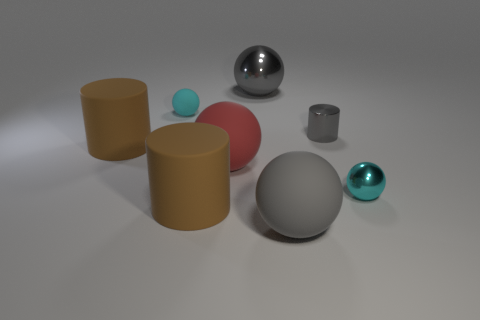There is a rubber thing that is the same color as the big metal thing; what size is it?
Keep it short and to the point. Large. What shape is the other metallic thing that is the same color as the big shiny thing?
Give a very brief answer. Cylinder. How many things are small gray shiny objects or tiny cyan things on the left side of the small shiny cylinder?
Give a very brief answer. 2. Is the size of the gray sphere in front of the red matte thing the same as the large red matte sphere?
Keep it short and to the point. Yes. What material is the small cyan sphere that is to the right of the small cyan rubber object?
Provide a succinct answer. Metal. Are there the same number of large gray rubber objects on the right side of the big red rubber thing and large brown matte objects to the right of the gray rubber object?
Keep it short and to the point. No. The other tiny shiny object that is the same shape as the red thing is what color?
Your answer should be very brief. Cyan. Is there any other thing that has the same color as the shiny cylinder?
Offer a terse response. Yes. What number of metallic things are either cylinders or small cyan things?
Offer a terse response. 2. Do the tiny metal sphere and the small matte sphere have the same color?
Your response must be concise. Yes. 